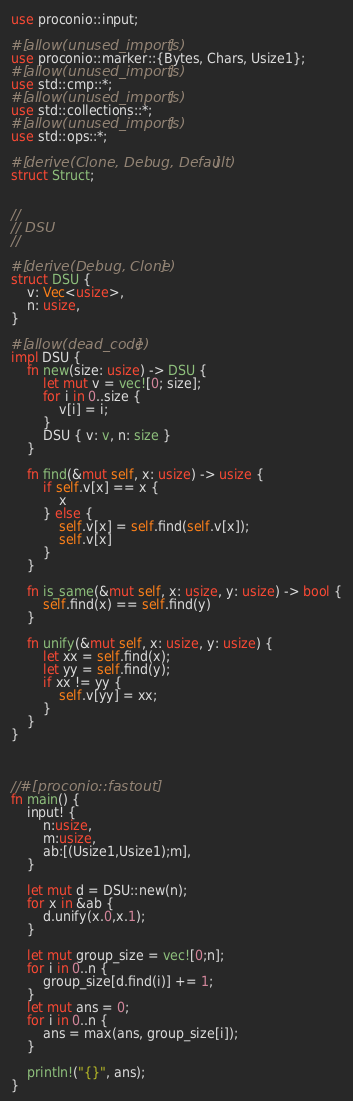Convert code to text. <code><loc_0><loc_0><loc_500><loc_500><_Rust_>use proconio::input;

#[allow(unused_imports)]
use proconio::marker::{Bytes, Chars, Usize1};
#[allow(unused_imports)]
use std::cmp::*;
#[allow(unused_imports)]
use std::collections::*;
#[allow(unused_imports)]
use std::ops::*;

#[derive(Clone, Debug, Default)]
struct Struct;


//
// DSU
//

#[derive(Debug, Clone)]
struct DSU {
    v: Vec<usize>,
    n: usize,
}

#[allow(dead_code)]
impl DSU {
    fn new(size: usize) -> DSU {
        let mut v = vec![0; size];
        for i in 0..size {
            v[i] = i;
        }
        DSU { v: v, n: size }
    }

    fn find(&mut self, x: usize) -> usize {
        if self.v[x] == x {
            x
        } else {
            self.v[x] = self.find(self.v[x]);
            self.v[x]
        }
    }

    fn is_same(&mut self, x: usize, y: usize) -> bool {
        self.find(x) == self.find(y)
    }

    fn unify(&mut self, x: usize, y: usize) {
        let xx = self.find(x);
        let yy = self.find(y);
        if xx != yy {
            self.v[yy] = xx;
        }
    }
}



//#[proconio::fastout]
fn main() {
    input! {
        n:usize,
        m:usize,
        ab:[(Usize1,Usize1);m],
    }

    let mut d = DSU::new(n);
    for x in &ab {
        d.unify(x.0,x.1);
    }

    let mut group_size = vec![0;n];
    for i in 0..n {
        group_size[d.find(i)] += 1;
    }
    let mut ans = 0;
    for i in 0..n {
        ans = max(ans, group_size[i]);
    }

    println!("{}", ans);
}
</code> 